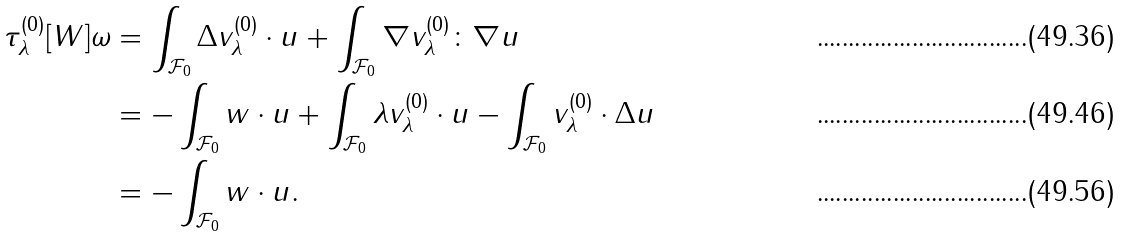<formula> <loc_0><loc_0><loc_500><loc_500>\tau _ { \lambda } ^ { ( 0 ) } [ W ] \omega & = \int _ { \mathcal { F } _ { 0 } } \Delta v ^ { ( 0 ) } _ { \lambda } \cdot u + \int _ { \mathcal { F } _ { 0 } } \nabla v _ { \lambda } ^ { ( 0 ) } \colon \nabla u \\ & = - \int _ { \mathcal { F } _ { 0 } } w \cdot u + \int _ { \mathcal { F } _ { 0 } } \lambda v ^ { ( 0 ) } _ { \lambda } \cdot u - \int _ { \mathcal { F } _ { 0 } } v ^ { ( 0 ) } _ { \lambda } \cdot \Delta u \\ & = - \int _ { \mathcal { F } _ { 0 } } w \cdot u .</formula> 